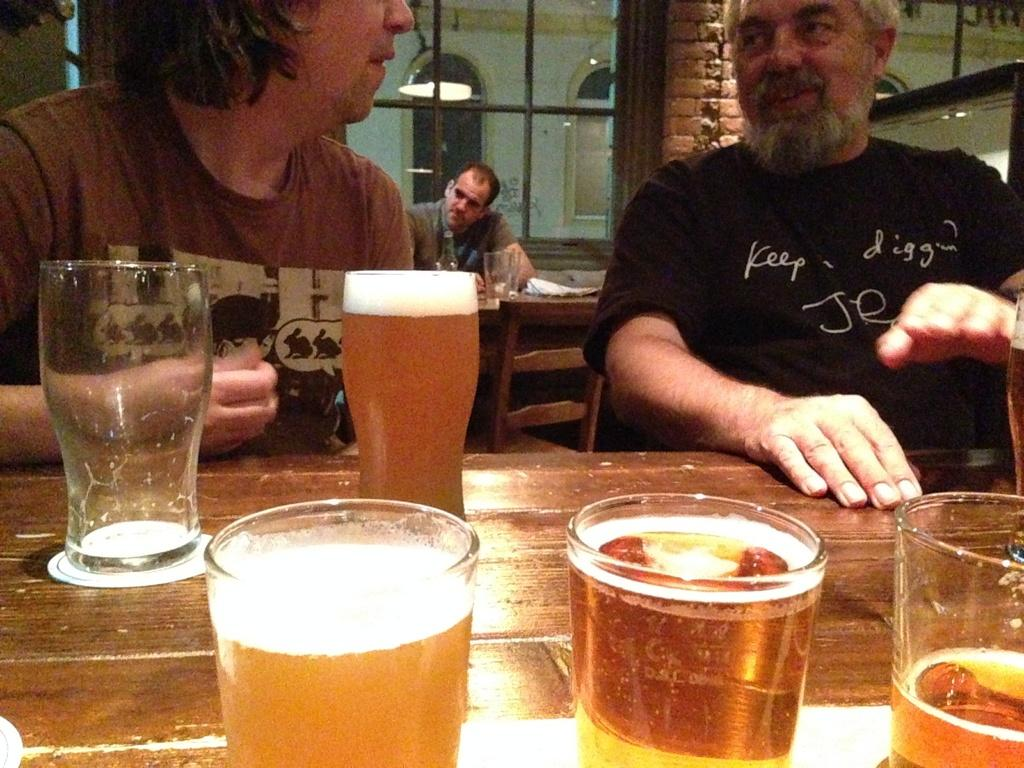How many people are in the image? There are three people in the image. What are the people doing in the image? The people are sitting on chairs. What is present on the table in the image? There is a table in the image, and there are glasses on the table. What is inside the glasses? There is a drink in the glasses. What type of unit can be seen in the cellar in the image? There is no cellar or unit present in the image. How does the health of the people in the image appear? The image does not provide any information about the health of the people. 